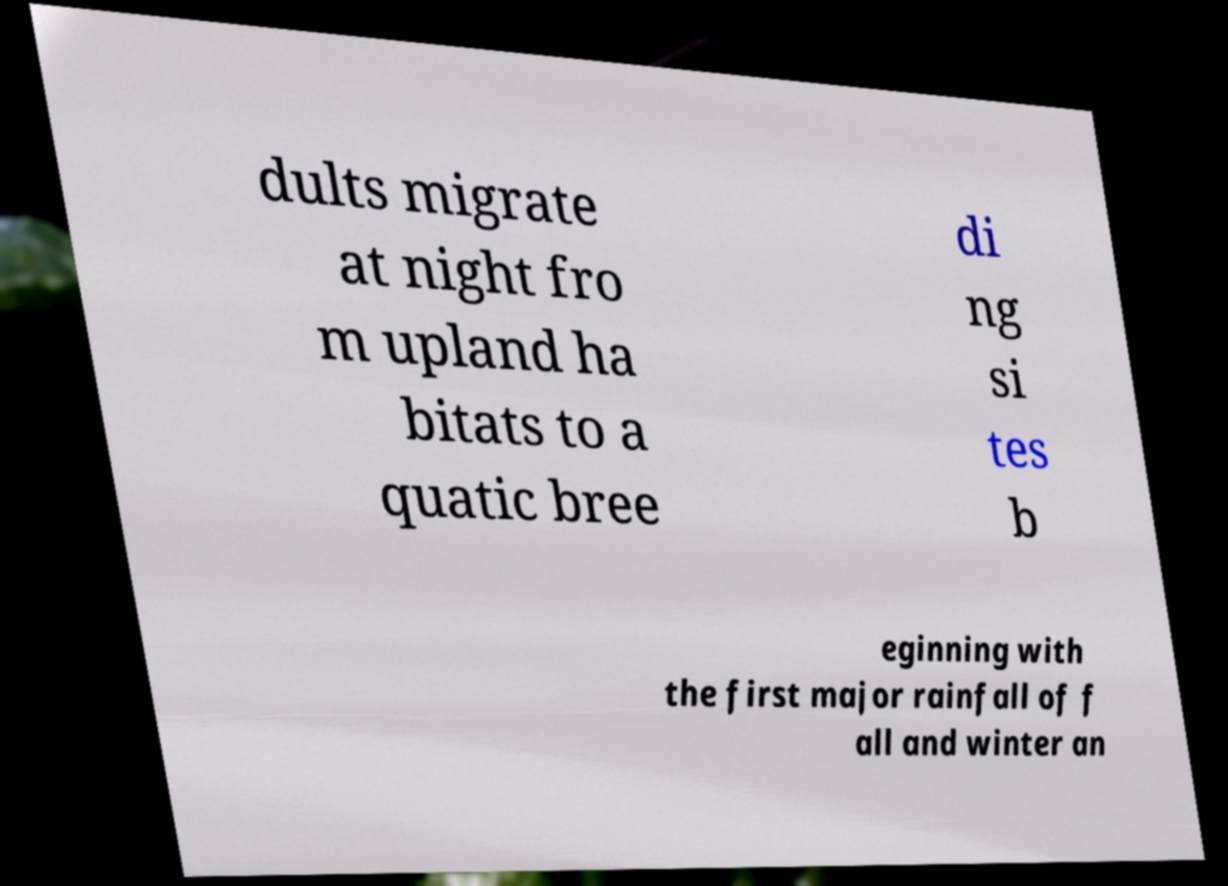Please identify and transcribe the text found in this image. dults migrate at night fro m upland ha bitats to a quatic bree di ng si tes b eginning with the first major rainfall of f all and winter an 